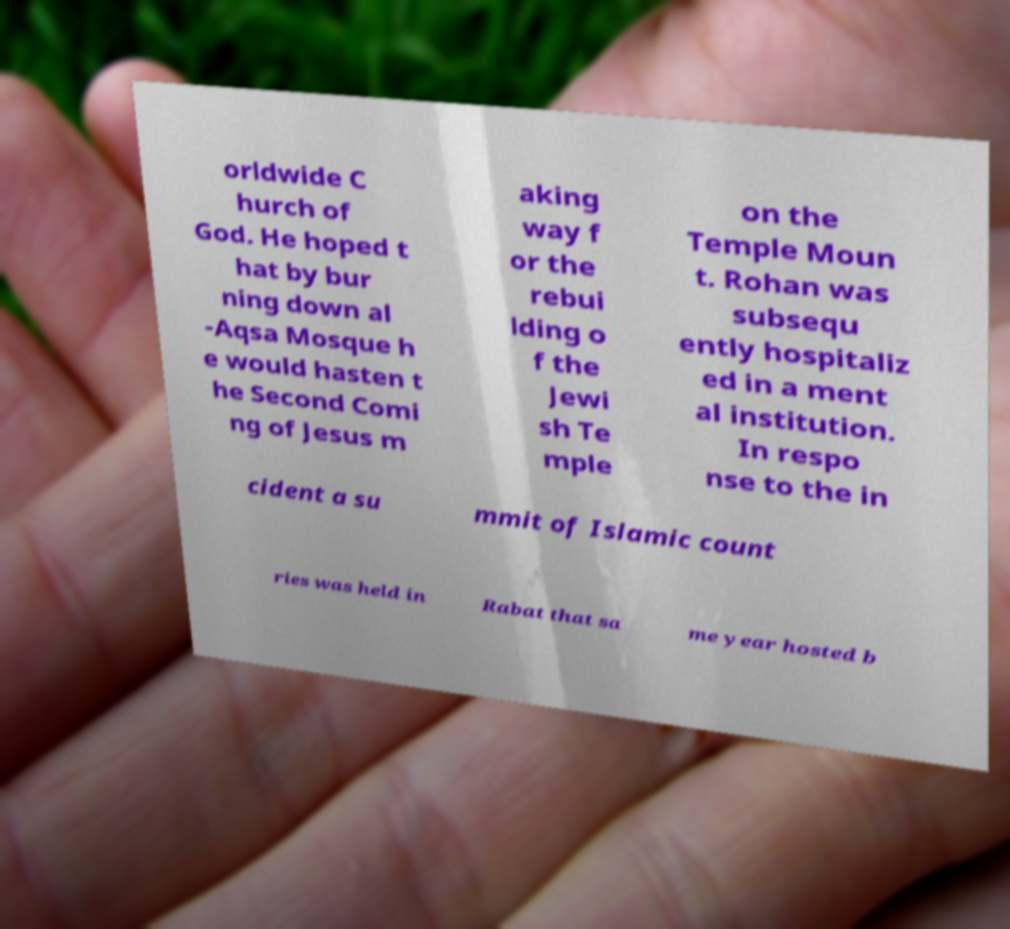Please read and relay the text visible in this image. What does it say? orldwide C hurch of God. He hoped t hat by bur ning down al -Aqsa Mosque h e would hasten t he Second Comi ng of Jesus m aking way f or the rebui lding o f the Jewi sh Te mple on the Temple Moun t. Rohan was subsequ ently hospitaliz ed in a ment al institution. In respo nse to the in cident a su mmit of Islamic count ries was held in Rabat that sa me year hosted b 